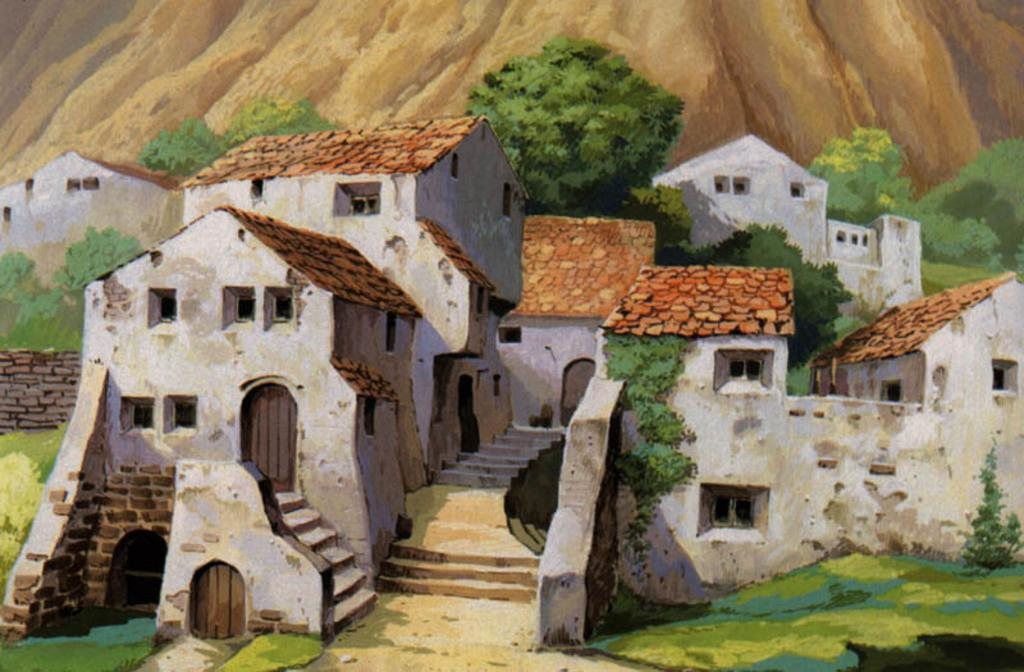What type of artwork is depicted in the image? The image is a painting. What natural elements can be seen in the painting? There are trees in the painting. What man-made structures are present in the painting? There are buildings in the painting. What geographical feature is at the top of the painting? There is a hill at the top of the painting. What type of ground is at the bottom of the painting? There is grass at the bottom of the painting. What type of furniture is visible in the painting? There is no furniture present in the painting; it features trees, buildings, a hill, and grass. What meal is being prepared in the painting? There is no meal preparation depicted in the painting; it is a landscape featuring trees, buildings, a hill, and grass. 